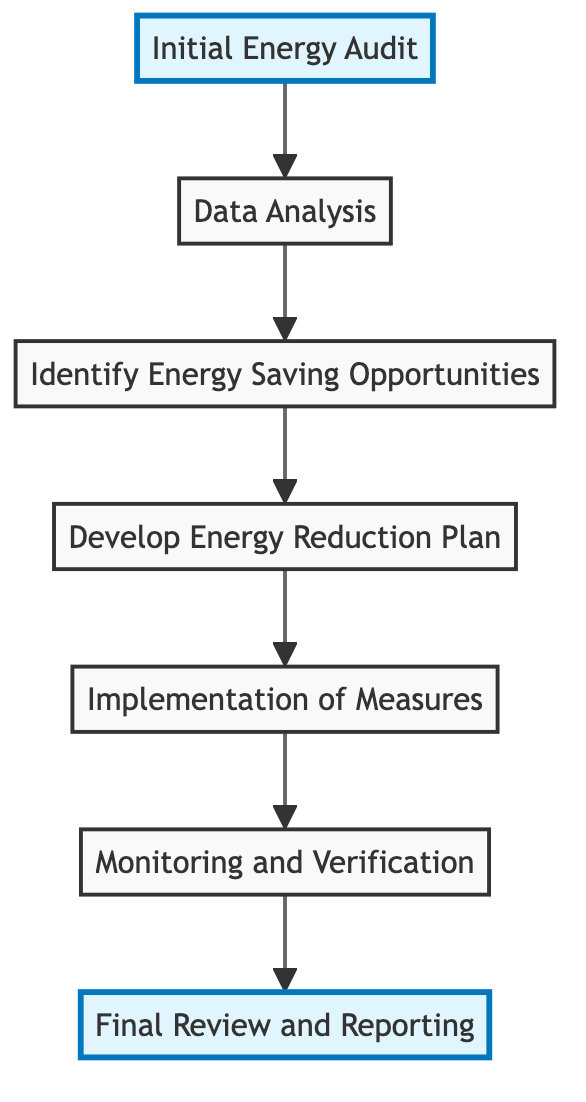What is the first step in the diagram? The first step is the "Initial Energy Audit" which is at the bottom of the flow chart.
Answer: Initial Energy Audit How many total steps are shown in the diagram? Counting each unique step from the initial energy audit to the final review, there are seven total steps.
Answer: 7 What is the last step in the flow chart? The last step in the flow chart is "Final Review and Reporting" which is located at the very top.
Answer: Final Review and Reporting Which step involves analyzing collected data? The step that involves analyzing collected data is "Data Analysis," which is the second step in the flow.
Answer: Data Analysis What follows the "Implementation of Measures"? The step that follows "Implementation of Measures" is "Monitoring and Verification," which checks the effectiveness of the previous measures.
Answer: Monitoring and Verification Which step requires collaboration with teams from different departments? The step that requires collaboration with teams from different departments is "Develop Energy Reduction Plan," as it entails detailing plans that ensure feasibility across departments.
Answer: Develop Energy Reduction Plan What is the main focus of "Identify Energy Saving Opportunities"? The main focus is to pinpoint specific opportunities for energy reduction such as upgrading systems and integrating technologies like VFDs.
Answer: Specific opportunities for energy reduction Which step is related to verification of project savings? The step related to verification of project savings is "Monitoring and Verification," which ensures actual savings meet projections.
Answer: Monitoring and Verification What is the direction of the flow in this diagram? The direction of the flow in this diagram is upwards, indicating a progression from initial audit to final review.
Answer: Upwards 